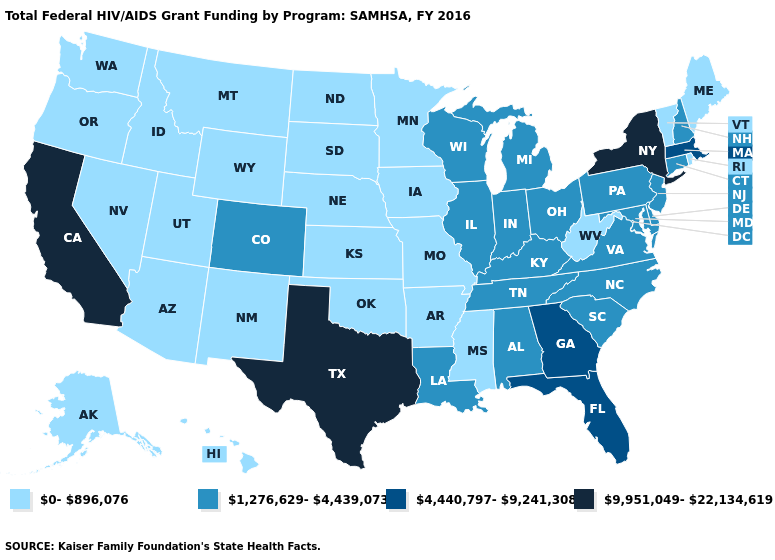Name the states that have a value in the range 0-896,076?
Quick response, please. Alaska, Arizona, Arkansas, Hawaii, Idaho, Iowa, Kansas, Maine, Minnesota, Mississippi, Missouri, Montana, Nebraska, Nevada, New Mexico, North Dakota, Oklahoma, Oregon, Rhode Island, South Dakota, Utah, Vermont, Washington, West Virginia, Wyoming. What is the lowest value in the West?
Write a very short answer. 0-896,076. Among the states that border Connecticut , which have the highest value?
Write a very short answer. New York. Does Texas have the highest value in the USA?
Be succinct. Yes. Does Texas have the highest value in the South?
Concise answer only. Yes. Does the first symbol in the legend represent the smallest category?
Short answer required. Yes. What is the lowest value in states that border New York?
Keep it brief. 0-896,076. Name the states that have a value in the range 9,951,049-22,134,619?
Be succinct. California, New York, Texas. What is the lowest value in the USA?
Concise answer only. 0-896,076. Does the map have missing data?
Concise answer only. No. Does Mississippi have a lower value than Hawaii?
Quick response, please. No. What is the value of South Carolina?
Keep it brief. 1,276,629-4,439,073. Which states hav the highest value in the South?
Be succinct. Texas. Is the legend a continuous bar?
Short answer required. No. 